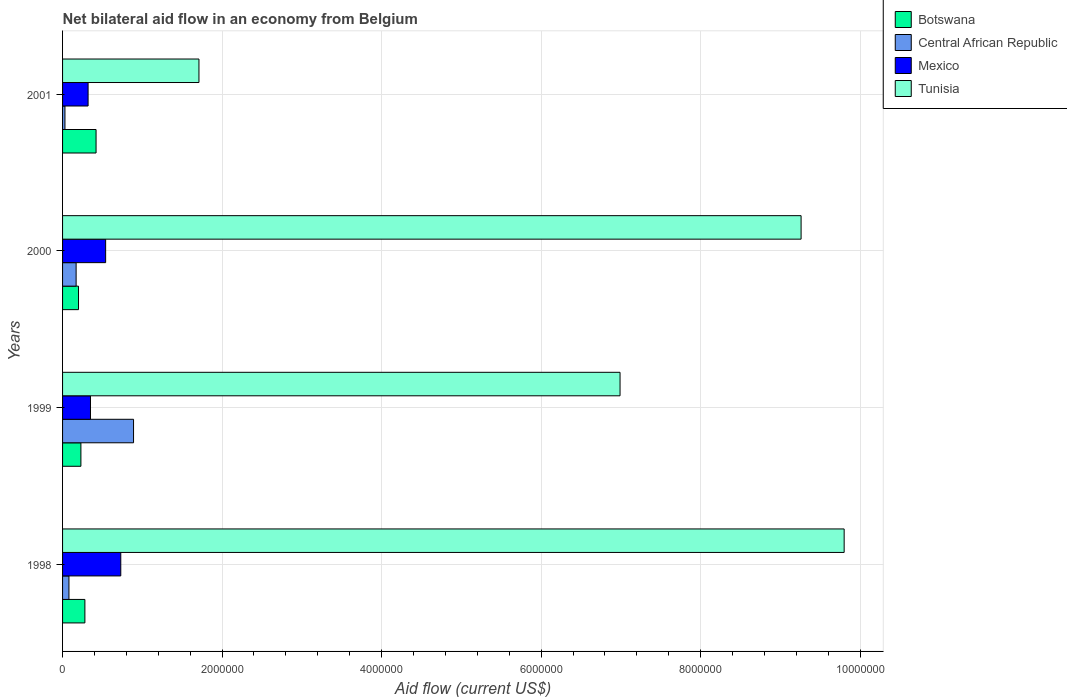How many different coloured bars are there?
Provide a short and direct response. 4. How many groups of bars are there?
Your response must be concise. 4. Are the number of bars per tick equal to the number of legend labels?
Make the answer very short. Yes. Are the number of bars on each tick of the Y-axis equal?
Give a very brief answer. Yes. How many bars are there on the 1st tick from the top?
Make the answer very short. 4. How many bars are there on the 3rd tick from the bottom?
Make the answer very short. 4. What is the net bilateral aid flow in Central African Republic in 2001?
Keep it short and to the point. 3.00e+04. Across all years, what is the maximum net bilateral aid flow in Mexico?
Offer a terse response. 7.30e+05. What is the total net bilateral aid flow in Tunisia in the graph?
Your answer should be very brief. 2.78e+07. What is the difference between the net bilateral aid flow in Mexico in 2000 and that in 2001?
Provide a succinct answer. 2.20e+05. What is the difference between the net bilateral aid flow in Mexico in 2000 and the net bilateral aid flow in Central African Republic in 1999?
Keep it short and to the point. -3.50e+05. What is the average net bilateral aid flow in Central African Republic per year?
Your answer should be compact. 2.92e+05. What is the ratio of the net bilateral aid flow in Central African Republic in 1998 to that in 2000?
Keep it short and to the point. 0.47. What is the difference between the highest and the second highest net bilateral aid flow in Mexico?
Provide a short and direct response. 1.90e+05. What is the difference between the highest and the lowest net bilateral aid flow in Mexico?
Offer a very short reply. 4.10e+05. Is the sum of the net bilateral aid flow in Tunisia in 2000 and 2001 greater than the maximum net bilateral aid flow in Central African Republic across all years?
Keep it short and to the point. Yes. What does the 3rd bar from the top in 1998 represents?
Provide a succinct answer. Central African Republic. What does the 2nd bar from the bottom in 1999 represents?
Your response must be concise. Central African Republic. How many bars are there?
Your answer should be compact. 16. How many years are there in the graph?
Make the answer very short. 4. What is the difference between two consecutive major ticks on the X-axis?
Provide a succinct answer. 2.00e+06. Does the graph contain grids?
Your answer should be compact. Yes. How many legend labels are there?
Make the answer very short. 4. How are the legend labels stacked?
Ensure brevity in your answer.  Vertical. What is the title of the graph?
Keep it short and to the point. Net bilateral aid flow in an economy from Belgium. Does "OECD members" appear as one of the legend labels in the graph?
Ensure brevity in your answer.  No. What is the label or title of the X-axis?
Your answer should be very brief. Aid flow (current US$). What is the Aid flow (current US$) in Mexico in 1998?
Make the answer very short. 7.30e+05. What is the Aid flow (current US$) in Tunisia in 1998?
Offer a terse response. 9.80e+06. What is the Aid flow (current US$) of Central African Republic in 1999?
Your response must be concise. 8.90e+05. What is the Aid flow (current US$) in Tunisia in 1999?
Give a very brief answer. 6.99e+06. What is the Aid flow (current US$) in Mexico in 2000?
Provide a short and direct response. 5.40e+05. What is the Aid flow (current US$) of Tunisia in 2000?
Make the answer very short. 9.26e+06. What is the Aid flow (current US$) of Central African Republic in 2001?
Your response must be concise. 3.00e+04. What is the Aid flow (current US$) of Mexico in 2001?
Ensure brevity in your answer.  3.20e+05. What is the Aid flow (current US$) in Tunisia in 2001?
Keep it short and to the point. 1.71e+06. Across all years, what is the maximum Aid flow (current US$) in Botswana?
Your answer should be very brief. 4.20e+05. Across all years, what is the maximum Aid flow (current US$) of Central African Republic?
Give a very brief answer. 8.90e+05. Across all years, what is the maximum Aid flow (current US$) of Mexico?
Your answer should be compact. 7.30e+05. Across all years, what is the maximum Aid flow (current US$) of Tunisia?
Provide a short and direct response. 9.80e+06. Across all years, what is the minimum Aid flow (current US$) of Botswana?
Your response must be concise. 2.00e+05. Across all years, what is the minimum Aid flow (current US$) of Mexico?
Provide a short and direct response. 3.20e+05. Across all years, what is the minimum Aid flow (current US$) in Tunisia?
Your answer should be compact. 1.71e+06. What is the total Aid flow (current US$) in Botswana in the graph?
Make the answer very short. 1.13e+06. What is the total Aid flow (current US$) of Central African Republic in the graph?
Offer a very short reply. 1.17e+06. What is the total Aid flow (current US$) in Mexico in the graph?
Ensure brevity in your answer.  1.94e+06. What is the total Aid flow (current US$) in Tunisia in the graph?
Ensure brevity in your answer.  2.78e+07. What is the difference between the Aid flow (current US$) in Central African Republic in 1998 and that in 1999?
Offer a terse response. -8.10e+05. What is the difference between the Aid flow (current US$) of Mexico in 1998 and that in 1999?
Make the answer very short. 3.80e+05. What is the difference between the Aid flow (current US$) of Tunisia in 1998 and that in 1999?
Offer a very short reply. 2.81e+06. What is the difference between the Aid flow (current US$) of Mexico in 1998 and that in 2000?
Offer a very short reply. 1.90e+05. What is the difference between the Aid flow (current US$) of Tunisia in 1998 and that in 2000?
Your response must be concise. 5.40e+05. What is the difference between the Aid flow (current US$) of Botswana in 1998 and that in 2001?
Keep it short and to the point. -1.40e+05. What is the difference between the Aid flow (current US$) in Mexico in 1998 and that in 2001?
Make the answer very short. 4.10e+05. What is the difference between the Aid flow (current US$) of Tunisia in 1998 and that in 2001?
Make the answer very short. 8.09e+06. What is the difference between the Aid flow (current US$) of Botswana in 1999 and that in 2000?
Make the answer very short. 3.00e+04. What is the difference between the Aid flow (current US$) in Central African Republic in 1999 and that in 2000?
Ensure brevity in your answer.  7.20e+05. What is the difference between the Aid flow (current US$) in Tunisia in 1999 and that in 2000?
Ensure brevity in your answer.  -2.27e+06. What is the difference between the Aid flow (current US$) in Botswana in 1999 and that in 2001?
Your answer should be compact. -1.90e+05. What is the difference between the Aid flow (current US$) of Central African Republic in 1999 and that in 2001?
Ensure brevity in your answer.  8.60e+05. What is the difference between the Aid flow (current US$) of Mexico in 1999 and that in 2001?
Ensure brevity in your answer.  3.00e+04. What is the difference between the Aid flow (current US$) in Tunisia in 1999 and that in 2001?
Provide a short and direct response. 5.28e+06. What is the difference between the Aid flow (current US$) in Botswana in 2000 and that in 2001?
Your answer should be very brief. -2.20e+05. What is the difference between the Aid flow (current US$) of Central African Republic in 2000 and that in 2001?
Your answer should be compact. 1.40e+05. What is the difference between the Aid flow (current US$) of Mexico in 2000 and that in 2001?
Ensure brevity in your answer.  2.20e+05. What is the difference between the Aid flow (current US$) of Tunisia in 2000 and that in 2001?
Your answer should be very brief. 7.55e+06. What is the difference between the Aid flow (current US$) in Botswana in 1998 and the Aid flow (current US$) in Central African Republic in 1999?
Your answer should be compact. -6.10e+05. What is the difference between the Aid flow (current US$) of Botswana in 1998 and the Aid flow (current US$) of Mexico in 1999?
Your answer should be very brief. -7.00e+04. What is the difference between the Aid flow (current US$) of Botswana in 1998 and the Aid flow (current US$) of Tunisia in 1999?
Ensure brevity in your answer.  -6.71e+06. What is the difference between the Aid flow (current US$) of Central African Republic in 1998 and the Aid flow (current US$) of Mexico in 1999?
Give a very brief answer. -2.70e+05. What is the difference between the Aid flow (current US$) in Central African Republic in 1998 and the Aid flow (current US$) in Tunisia in 1999?
Provide a succinct answer. -6.91e+06. What is the difference between the Aid flow (current US$) of Mexico in 1998 and the Aid flow (current US$) of Tunisia in 1999?
Your response must be concise. -6.26e+06. What is the difference between the Aid flow (current US$) in Botswana in 1998 and the Aid flow (current US$) in Central African Republic in 2000?
Offer a very short reply. 1.10e+05. What is the difference between the Aid flow (current US$) in Botswana in 1998 and the Aid flow (current US$) in Mexico in 2000?
Offer a very short reply. -2.60e+05. What is the difference between the Aid flow (current US$) in Botswana in 1998 and the Aid flow (current US$) in Tunisia in 2000?
Offer a very short reply. -8.98e+06. What is the difference between the Aid flow (current US$) in Central African Republic in 1998 and the Aid flow (current US$) in Mexico in 2000?
Your response must be concise. -4.60e+05. What is the difference between the Aid flow (current US$) of Central African Republic in 1998 and the Aid flow (current US$) of Tunisia in 2000?
Your response must be concise. -9.18e+06. What is the difference between the Aid flow (current US$) in Mexico in 1998 and the Aid flow (current US$) in Tunisia in 2000?
Offer a very short reply. -8.53e+06. What is the difference between the Aid flow (current US$) of Botswana in 1998 and the Aid flow (current US$) of Central African Republic in 2001?
Ensure brevity in your answer.  2.50e+05. What is the difference between the Aid flow (current US$) in Botswana in 1998 and the Aid flow (current US$) in Mexico in 2001?
Ensure brevity in your answer.  -4.00e+04. What is the difference between the Aid flow (current US$) in Botswana in 1998 and the Aid flow (current US$) in Tunisia in 2001?
Keep it short and to the point. -1.43e+06. What is the difference between the Aid flow (current US$) of Central African Republic in 1998 and the Aid flow (current US$) of Tunisia in 2001?
Offer a terse response. -1.63e+06. What is the difference between the Aid flow (current US$) in Mexico in 1998 and the Aid flow (current US$) in Tunisia in 2001?
Ensure brevity in your answer.  -9.80e+05. What is the difference between the Aid flow (current US$) of Botswana in 1999 and the Aid flow (current US$) of Central African Republic in 2000?
Offer a terse response. 6.00e+04. What is the difference between the Aid flow (current US$) of Botswana in 1999 and the Aid flow (current US$) of Mexico in 2000?
Your answer should be very brief. -3.10e+05. What is the difference between the Aid flow (current US$) of Botswana in 1999 and the Aid flow (current US$) of Tunisia in 2000?
Make the answer very short. -9.03e+06. What is the difference between the Aid flow (current US$) in Central African Republic in 1999 and the Aid flow (current US$) in Mexico in 2000?
Ensure brevity in your answer.  3.50e+05. What is the difference between the Aid flow (current US$) in Central African Republic in 1999 and the Aid flow (current US$) in Tunisia in 2000?
Keep it short and to the point. -8.37e+06. What is the difference between the Aid flow (current US$) in Mexico in 1999 and the Aid flow (current US$) in Tunisia in 2000?
Keep it short and to the point. -8.91e+06. What is the difference between the Aid flow (current US$) in Botswana in 1999 and the Aid flow (current US$) in Tunisia in 2001?
Your answer should be compact. -1.48e+06. What is the difference between the Aid flow (current US$) in Central African Republic in 1999 and the Aid flow (current US$) in Mexico in 2001?
Offer a terse response. 5.70e+05. What is the difference between the Aid flow (current US$) of Central African Republic in 1999 and the Aid flow (current US$) of Tunisia in 2001?
Offer a very short reply. -8.20e+05. What is the difference between the Aid flow (current US$) in Mexico in 1999 and the Aid flow (current US$) in Tunisia in 2001?
Offer a very short reply. -1.36e+06. What is the difference between the Aid flow (current US$) of Botswana in 2000 and the Aid flow (current US$) of Mexico in 2001?
Give a very brief answer. -1.20e+05. What is the difference between the Aid flow (current US$) in Botswana in 2000 and the Aid flow (current US$) in Tunisia in 2001?
Provide a succinct answer. -1.51e+06. What is the difference between the Aid flow (current US$) in Central African Republic in 2000 and the Aid flow (current US$) in Mexico in 2001?
Your answer should be compact. -1.50e+05. What is the difference between the Aid flow (current US$) in Central African Republic in 2000 and the Aid flow (current US$) in Tunisia in 2001?
Keep it short and to the point. -1.54e+06. What is the difference between the Aid flow (current US$) in Mexico in 2000 and the Aid flow (current US$) in Tunisia in 2001?
Your answer should be very brief. -1.17e+06. What is the average Aid flow (current US$) in Botswana per year?
Keep it short and to the point. 2.82e+05. What is the average Aid flow (current US$) of Central African Republic per year?
Make the answer very short. 2.92e+05. What is the average Aid flow (current US$) of Mexico per year?
Make the answer very short. 4.85e+05. What is the average Aid flow (current US$) of Tunisia per year?
Make the answer very short. 6.94e+06. In the year 1998, what is the difference between the Aid flow (current US$) of Botswana and Aid flow (current US$) of Mexico?
Ensure brevity in your answer.  -4.50e+05. In the year 1998, what is the difference between the Aid flow (current US$) in Botswana and Aid flow (current US$) in Tunisia?
Make the answer very short. -9.52e+06. In the year 1998, what is the difference between the Aid flow (current US$) in Central African Republic and Aid flow (current US$) in Mexico?
Provide a succinct answer. -6.50e+05. In the year 1998, what is the difference between the Aid flow (current US$) of Central African Republic and Aid flow (current US$) of Tunisia?
Your response must be concise. -9.72e+06. In the year 1998, what is the difference between the Aid flow (current US$) in Mexico and Aid flow (current US$) in Tunisia?
Ensure brevity in your answer.  -9.07e+06. In the year 1999, what is the difference between the Aid flow (current US$) of Botswana and Aid flow (current US$) of Central African Republic?
Offer a terse response. -6.60e+05. In the year 1999, what is the difference between the Aid flow (current US$) in Botswana and Aid flow (current US$) in Mexico?
Give a very brief answer. -1.20e+05. In the year 1999, what is the difference between the Aid flow (current US$) in Botswana and Aid flow (current US$) in Tunisia?
Ensure brevity in your answer.  -6.76e+06. In the year 1999, what is the difference between the Aid flow (current US$) of Central African Republic and Aid flow (current US$) of Mexico?
Provide a succinct answer. 5.40e+05. In the year 1999, what is the difference between the Aid flow (current US$) of Central African Republic and Aid flow (current US$) of Tunisia?
Your response must be concise. -6.10e+06. In the year 1999, what is the difference between the Aid flow (current US$) of Mexico and Aid flow (current US$) of Tunisia?
Keep it short and to the point. -6.64e+06. In the year 2000, what is the difference between the Aid flow (current US$) of Botswana and Aid flow (current US$) of Central African Republic?
Provide a short and direct response. 3.00e+04. In the year 2000, what is the difference between the Aid flow (current US$) of Botswana and Aid flow (current US$) of Mexico?
Ensure brevity in your answer.  -3.40e+05. In the year 2000, what is the difference between the Aid flow (current US$) in Botswana and Aid flow (current US$) in Tunisia?
Provide a short and direct response. -9.06e+06. In the year 2000, what is the difference between the Aid flow (current US$) in Central African Republic and Aid flow (current US$) in Mexico?
Provide a succinct answer. -3.70e+05. In the year 2000, what is the difference between the Aid flow (current US$) of Central African Republic and Aid flow (current US$) of Tunisia?
Keep it short and to the point. -9.09e+06. In the year 2000, what is the difference between the Aid flow (current US$) of Mexico and Aid flow (current US$) of Tunisia?
Offer a terse response. -8.72e+06. In the year 2001, what is the difference between the Aid flow (current US$) of Botswana and Aid flow (current US$) of Central African Republic?
Provide a short and direct response. 3.90e+05. In the year 2001, what is the difference between the Aid flow (current US$) of Botswana and Aid flow (current US$) of Tunisia?
Offer a terse response. -1.29e+06. In the year 2001, what is the difference between the Aid flow (current US$) of Central African Republic and Aid flow (current US$) of Mexico?
Offer a very short reply. -2.90e+05. In the year 2001, what is the difference between the Aid flow (current US$) of Central African Republic and Aid flow (current US$) of Tunisia?
Make the answer very short. -1.68e+06. In the year 2001, what is the difference between the Aid flow (current US$) in Mexico and Aid flow (current US$) in Tunisia?
Offer a very short reply. -1.39e+06. What is the ratio of the Aid flow (current US$) in Botswana in 1998 to that in 1999?
Provide a succinct answer. 1.22. What is the ratio of the Aid flow (current US$) in Central African Republic in 1998 to that in 1999?
Your response must be concise. 0.09. What is the ratio of the Aid flow (current US$) of Mexico in 1998 to that in 1999?
Keep it short and to the point. 2.09. What is the ratio of the Aid flow (current US$) in Tunisia in 1998 to that in 1999?
Provide a short and direct response. 1.4. What is the ratio of the Aid flow (current US$) in Central African Republic in 1998 to that in 2000?
Ensure brevity in your answer.  0.47. What is the ratio of the Aid flow (current US$) in Mexico in 1998 to that in 2000?
Ensure brevity in your answer.  1.35. What is the ratio of the Aid flow (current US$) of Tunisia in 1998 to that in 2000?
Give a very brief answer. 1.06. What is the ratio of the Aid flow (current US$) in Botswana in 1998 to that in 2001?
Offer a terse response. 0.67. What is the ratio of the Aid flow (current US$) of Central African Republic in 1998 to that in 2001?
Your response must be concise. 2.67. What is the ratio of the Aid flow (current US$) in Mexico in 1998 to that in 2001?
Make the answer very short. 2.28. What is the ratio of the Aid flow (current US$) of Tunisia in 1998 to that in 2001?
Offer a terse response. 5.73. What is the ratio of the Aid flow (current US$) in Botswana in 1999 to that in 2000?
Offer a terse response. 1.15. What is the ratio of the Aid flow (current US$) in Central African Republic in 1999 to that in 2000?
Ensure brevity in your answer.  5.24. What is the ratio of the Aid flow (current US$) in Mexico in 1999 to that in 2000?
Your response must be concise. 0.65. What is the ratio of the Aid flow (current US$) in Tunisia in 1999 to that in 2000?
Your answer should be very brief. 0.75. What is the ratio of the Aid flow (current US$) in Botswana in 1999 to that in 2001?
Keep it short and to the point. 0.55. What is the ratio of the Aid flow (current US$) in Central African Republic in 1999 to that in 2001?
Give a very brief answer. 29.67. What is the ratio of the Aid flow (current US$) of Mexico in 1999 to that in 2001?
Make the answer very short. 1.09. What is the ratio of the Aid flow (current US$) in Tunisia in 1999 to that in 2001?
Your answer should be compact. 4.09. What is the ratio of the Aid flow (current US$) in Botswana in 2000 to that in 2001?
Offer a terse response. 0.48. What is the ratio of the Aid flow (current US$) in Central African Republic in 2000 to that in 2001?
Your response must be concise. 5.67. What is the ratio of the Aid flow (current US$) in Mexico in 2000 to that in 2001?
Provide a short and direct response. 1.69. What is the ratio of the Aid flow (current US$) in Tunisia in 2000 to that in 2001?
Keep it short and to the point. 5.42. What is the difference between the highest and the second highest Aid flow (current US$) of Botswana?
Offer a terse response. 1.40e+05. What is the difference between the highest and the second highest Aid flow (current US$) of Central African Republic?
Ensure brevity in your answer.  7.20e+05. What is the difference between the highest and the second highest Aid flow (current US$) in Mexico?
Offer a very short reply. 1.90e+05. What is the difference between the highest and the second highest Aid flow (current US$) of Tunisia?
Your response must be concise. 5.40e+05. What is the difference between the highest and the lowest Aid flow (current US$) in Botswana?
Offer a very short reply. 2.20e+05. What is the difference between the highest and the lowest Aid flow (current US$) in Central African Republic?
Your response must be concise. 8.60e+05. What is the difference between the highest and the lowest Aid flow (current US$) of Tunisia?
Your answer should be very brief. 8.09e+06. 